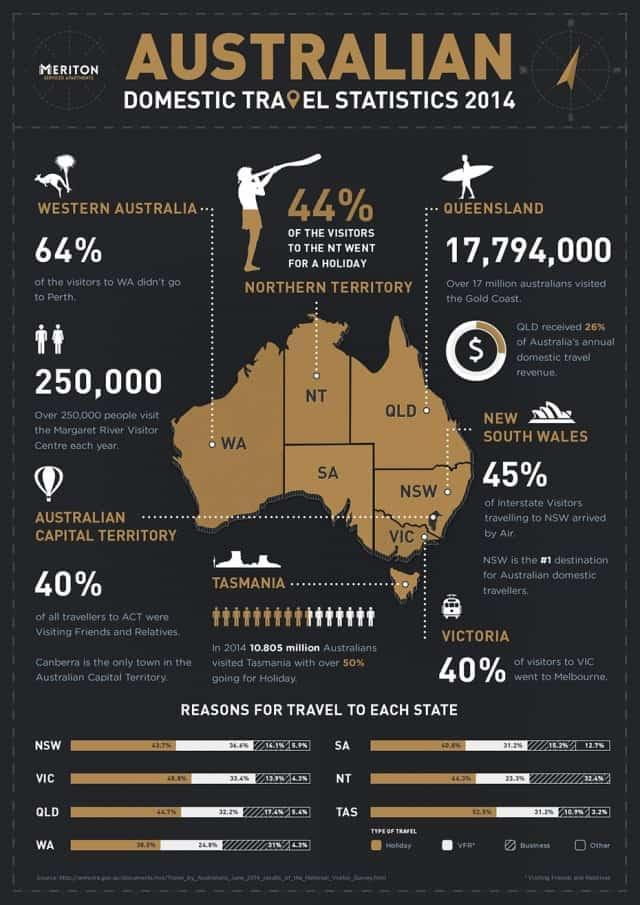What percentage of the visitors to WA didn't go to Perth?
Answer the question with a short phrase. 64% Which is the least visited domestic destination in Western Australia in the year 2014? Perth Which is the only town in the Australian Capital Territory? Canberra How many states in Australia are mentioned here? 7 Which is the most visited domestic destination in Australia in the year 2014? Tasmania What is the widely used mode of transport for the travellers who visited New South Wales in the year 2014? Air What percentage of Victoria visitors didn't go to Melbourne? 60% 